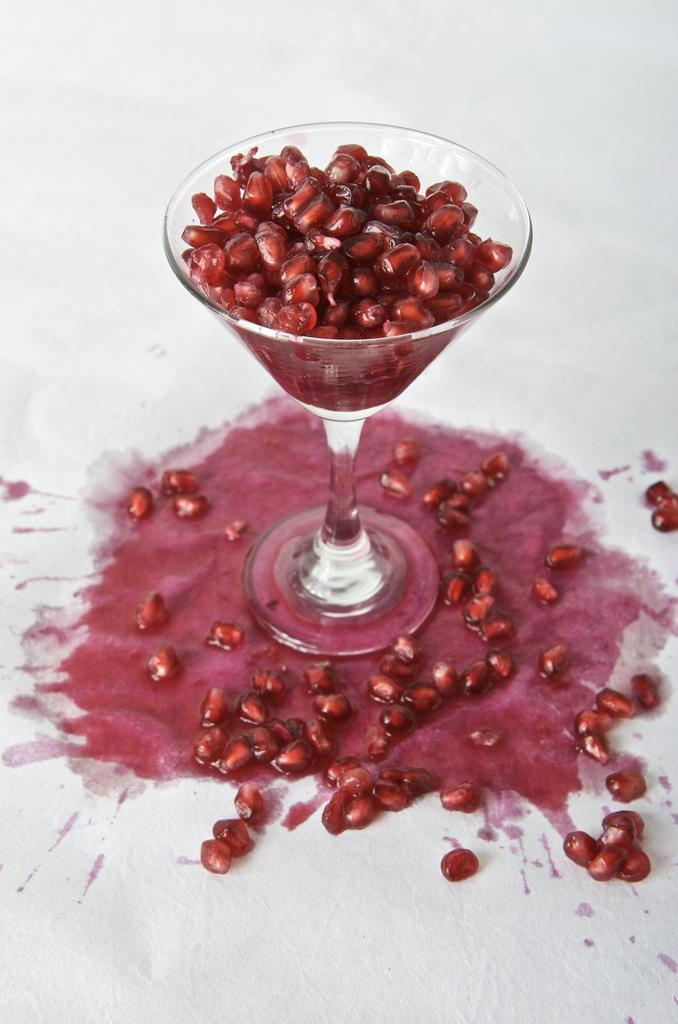What is in the glass that is visible in the image? There is a glass in the image, and it contains pomegranate seeds. Can you describe the contents of the glass in more detail? Yes, there are pomegranate seeds at the bottom of the glass, and the juice of the pomegranate is visible in the glass. What type of floor can be seen in the image? There is no floor visible in the image; it only shows a glass containing pomegranate seeds and juice. 